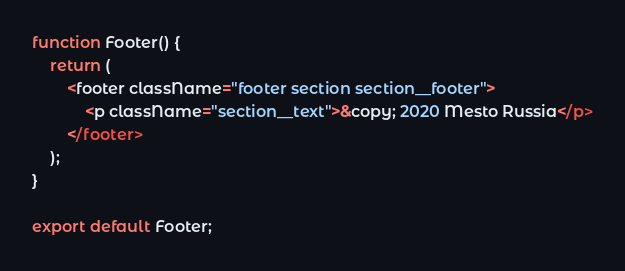<code> <loc_0><loc_0><loc_500><loc_500><_JavaScript_>function Footer() {
    return (
        <footer className="footer section section__footer">
            <p className="section__text">&copy; 2020 Mesto Russia</p>
        </footer>
    );
}

export default Footer;
</code> 